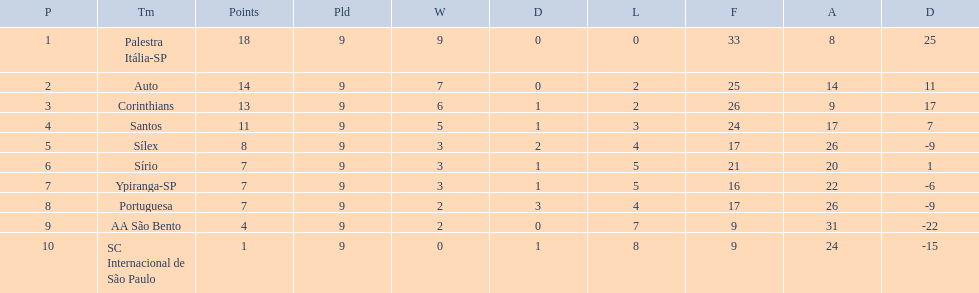Brazilian football in 1926 what teams had no draws? Palestra Itália-SP, Auto, AA São Bento. Of the teams with no draws name the 2 who lost the lease. Palestra Itália-SP, Auto. What team of the 2 who lost the least and had no draws had the highest difference? Palestra Itália-SP. 